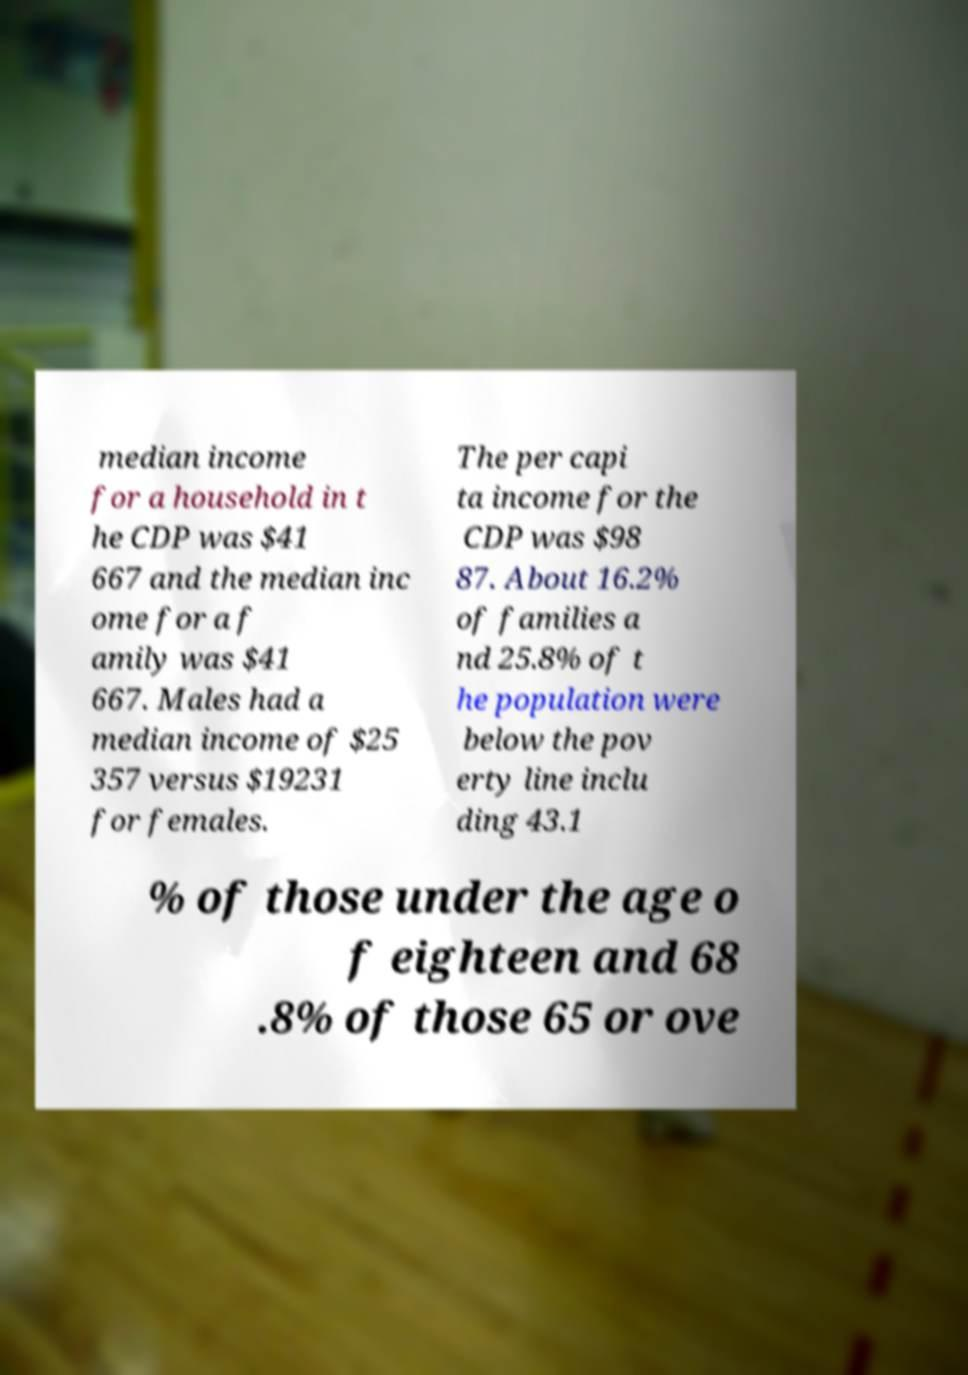Please identify and transcribe the text found in this image. median income for a household in t he CDP was $41 667 and the median inc ome for a f amily was $41 667. Males had a median income of $25 357 versus $19231 for females. The per capi ta income for the CDP was $98 87. About 16.2% of families a nd 25.8% of t he population were below the pov erty line inclu ding 43.1 % of those under the age o f eighteen and 68 .8% of those 65 or ove 